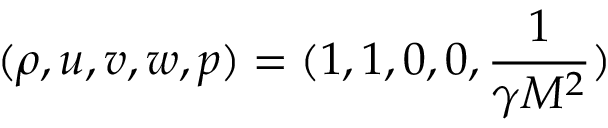Convert formula to latex. <formula><loc_0><loc_0><loc_500><loc_500>( \rho , u , v , w , p ) = ( 1 , 1 , 0 , 0 , \frac { 1 } { \gamma M ^ { 2 } } )</formula> 